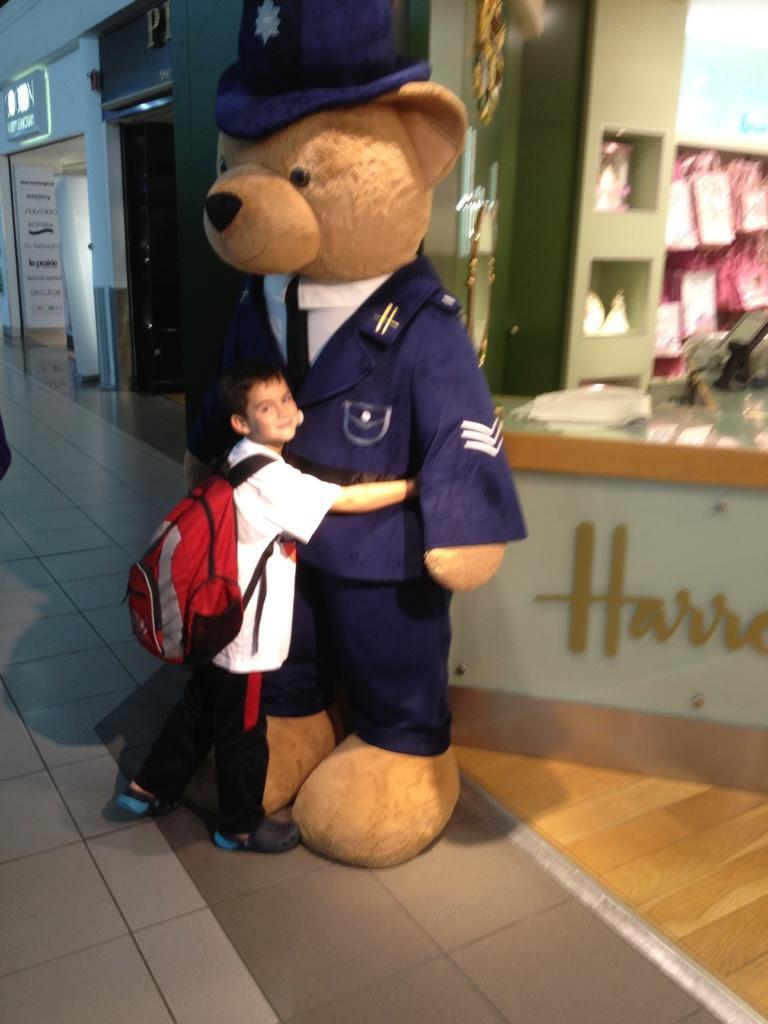In one or two sentences, can you explain what this image depicts? In this image I see a boy who is wearing white shirt and black pants and I see that he is hugging a teddy bear which is of brown in color and I see that there are clothes and a cap on teddy bear and I see a shop over here and I see a word written over here and I see the path. 